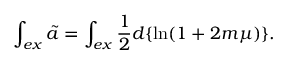Convert formula to latex. <formula><loc_0><loc_0><loc_500><loc_500>\int _ { e x } \tilde { a } = \int _ { e x } \frac { 1 } { 2 } d \{ \ln ( 1 + 2 m \mu ) \} .</formula> 